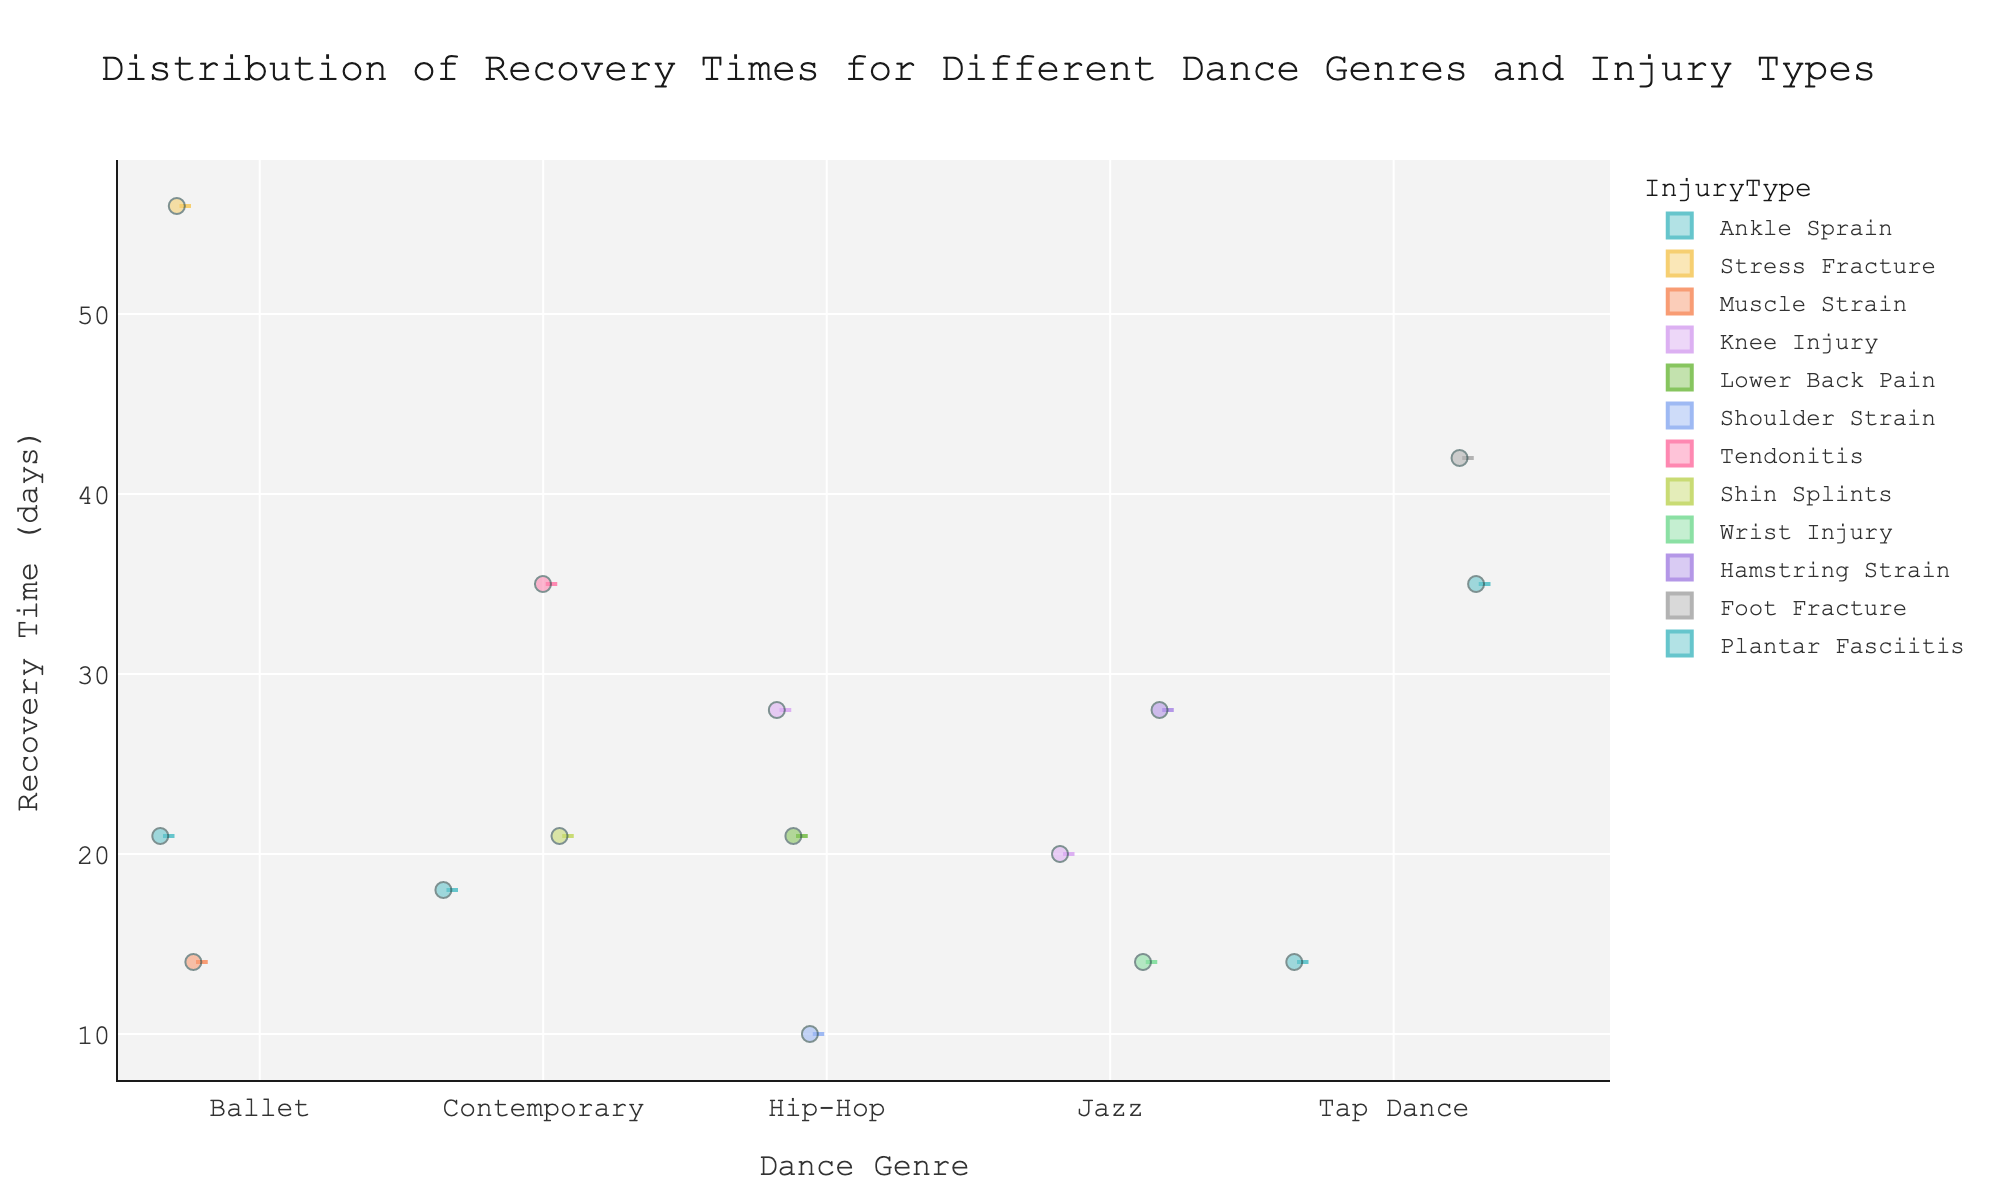What is the title of the figure? The title of the figure is usually placed at the top and it gives an overview of what the figure represents. In this case, it describes the distribution of recovery times for different dance genres and injury types.
Answer: Distribution of Recovery Times for Different Dance Genres and Injury Types What is the X-axis representing in the chart? The X-axis in a violin plot like this one typically represents categorical data. Here, it shows the different genres of dance.
Answer: Dance Genre How many dance genres are displayed in the figure? To answer this question, we count the distinct categories on the X-axis. From the data, we see Ballet, Contemporary, Hip-Hop, Jazz, and Tap Dance.
Answer: 5 Which dance genre has the longest recovery time displayed? The longest recovery time can be found by observing the highest point on the Y-axis for each genre. Ballet has the highest point at 56 days.
Answer: Ballet What is the range of recovery times for Hip-Hop dancers? We need to look at the points spread on the Y-axis within the Hip-Hop category. The lowest is 10 days, and the highest is 28 days.
Answer: 10 to 28 days Is there a genre where the median recovery time is particularly low? The median is often represented by a line within the violin plot. By checking the middle lines in each genre, we see that Ballet has a relatively lower median recovery time.
Answer: Ballet Which injury type has the widest spread of recovery times in Tap Dance? We observe the range of recovery times for each injury type within the Tap Dance genre and look for the one with the largest spread. Plantar Fasciitis ranges from 35 to 42 days.
Answer: Plantar Fasciitis Which genre has the most data points for injury recovery times? We count the number of dots (data points) within each violin shape. Hip-Hop, Contemporary, Jazz, and Tap Dance have 3 data points each, and Ballet has 3.
Answer: Contemporary, Hip-Hop, Jazz, Tap Dance, Ballet What is the median recovery time for Contemporary dancers? The median is represented by a horizontal line within the violin shape. In Contemporary, the median line is around 35 days.
Answer: 35 days Is there any genre where no injury type has a recovery time below 14 days? We check each genre to see if all injury types have recovery times above 14 days. Ballet has all injuries above 14 days.
Answer: Ballet 